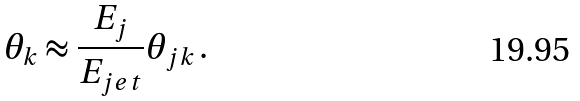Convert formula to latex. <formula><loc_0><loc_0><loc_500><loc_500>\theta _ { k } \approx \frac { E _ { j } } { E _ { j e t } } \theta _ { j k } \, .</formula> 